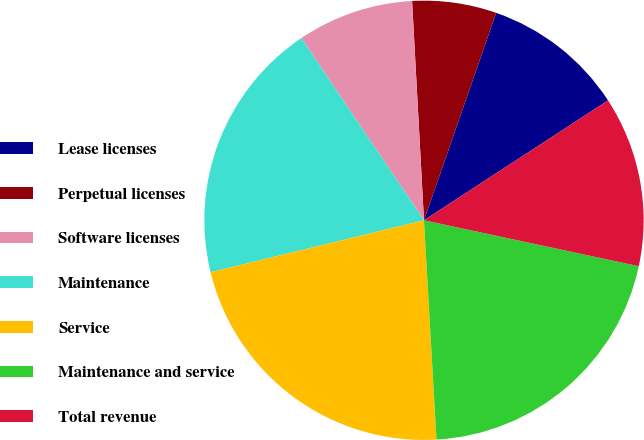<chart> <loc_0><loc_0><loc_500><loc_500><pie_chart><fcel>Lease licenses<fcel>Perpetual licenses<fcel>Software licenses<fcel>Maintenance<fcel>Service<fcel>Maintenance and service<fcel>Total revenue<nl><fcel>10.48%<fcel>6.19%<fcel>8.57%<fcel>19.37%<fcel>22.1%<fcel>20.74%<fcel>12.54%<nl></chart> 